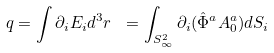<formula> <loc_0><loc_0><loc_500><loc_500>q = \int { \partial _ { i } E _ { i } d ^ { 3 } r } \ = \int _ { S _ { \infty } ^ { 2 } } \partial _ { i } ( \hat { \Phi } ^ { a } A _ { 0 } ^ { a } ) d S _ { i }</formula> 